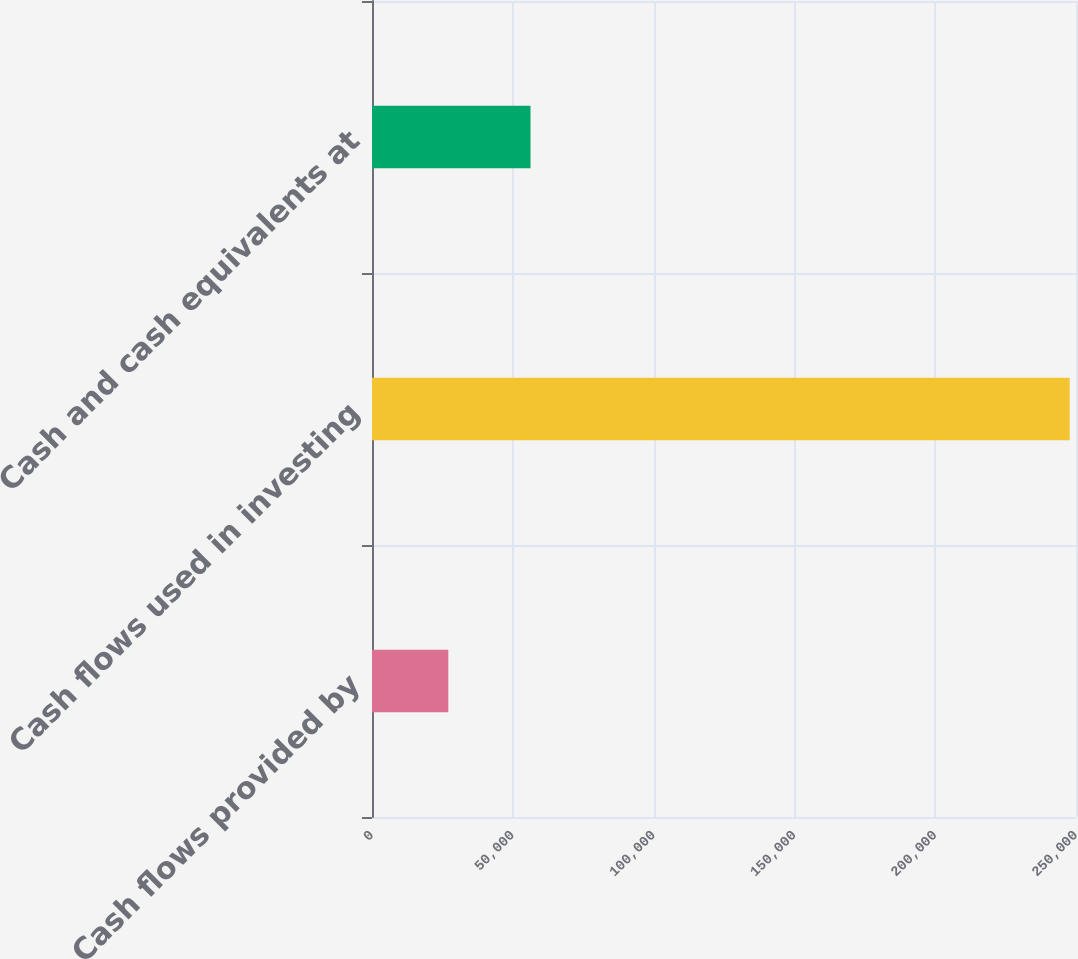Convert chart. <chart><loc_0><loc_0><loc_500><loc_500><bar_chart><fcel>Cash flows provided by<fcel>Cash flows used in investing<fcel>Cash and cash equivalents at<nl><fcel>27098<fcel>247757<fcel>56292<nl></chart> 